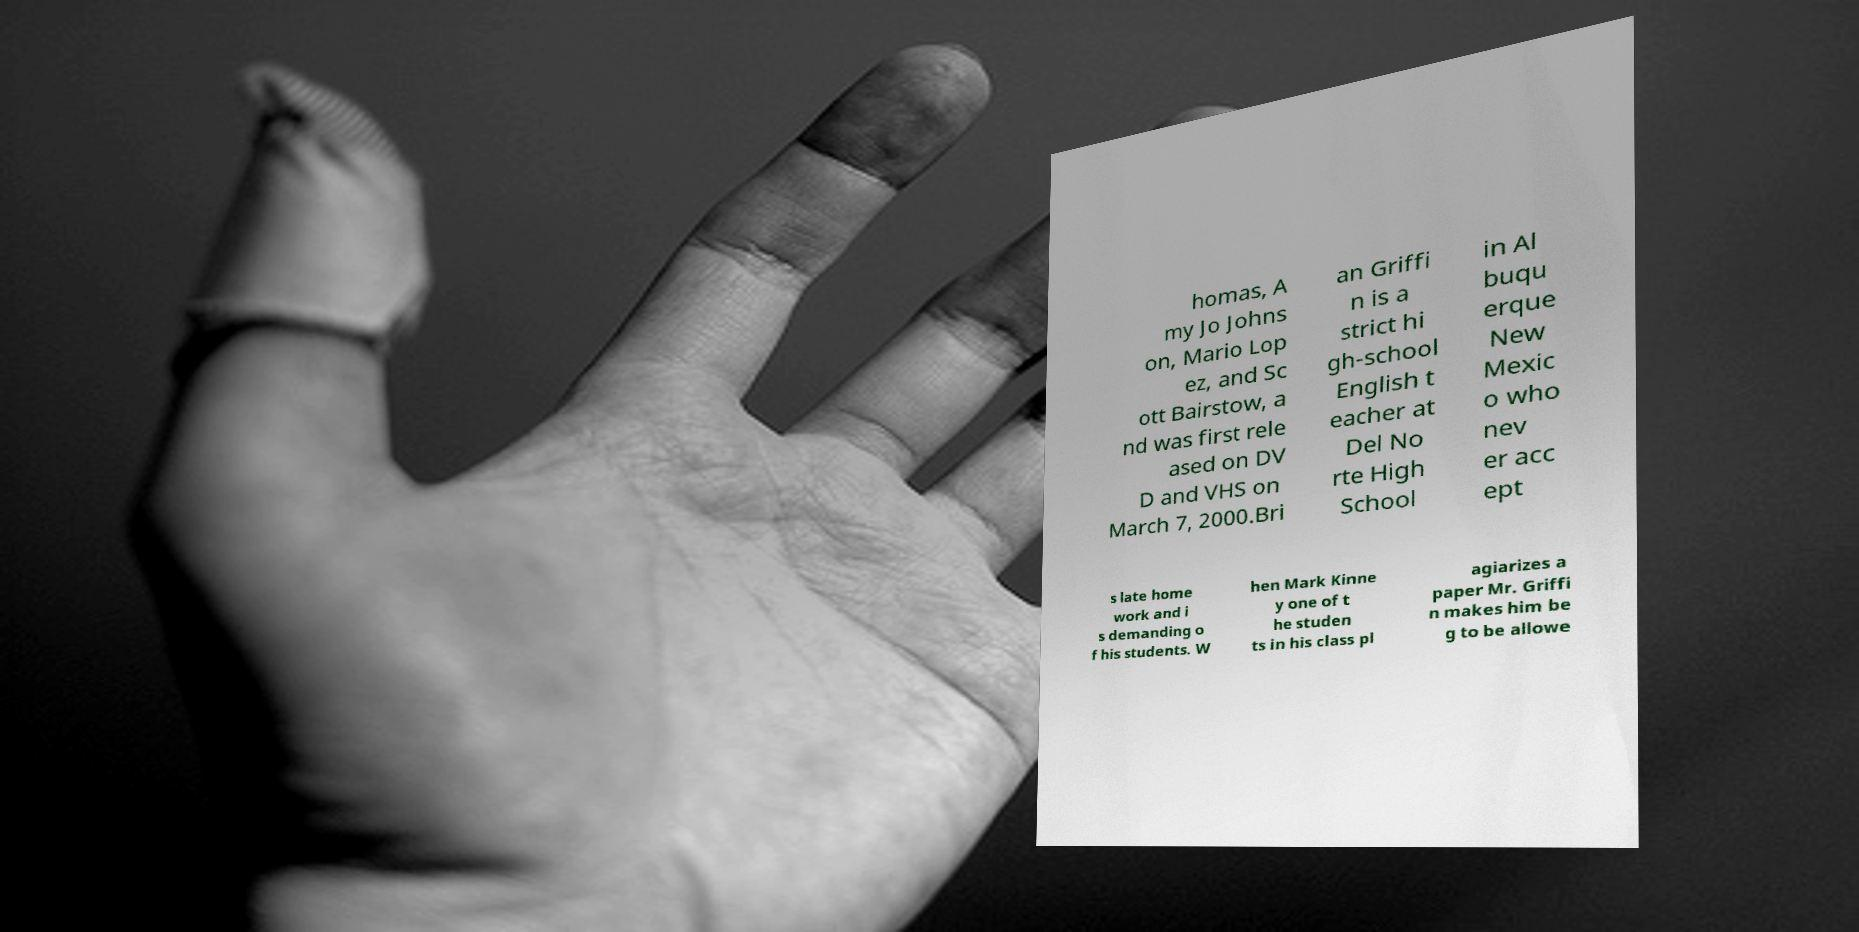Please read and relay the text visible in this image. What does it say? homas, A my Jo Johns on, Mario Lop ez, and Sc ott Bairstow, a nd was first rele ased on DV D and VHS on March 7, 2000.Bri an Griffi n is a strict hi gh-school English t eacher at Del No rte High School in Al buqu erque New Mexic o who nev er acc ept s late home work and i s demanding o f his students. W hen Mark Kinne y one of t he studen ts in his class pl agiarizes a paper Mr. Griffi n makes him be g to be allowe 